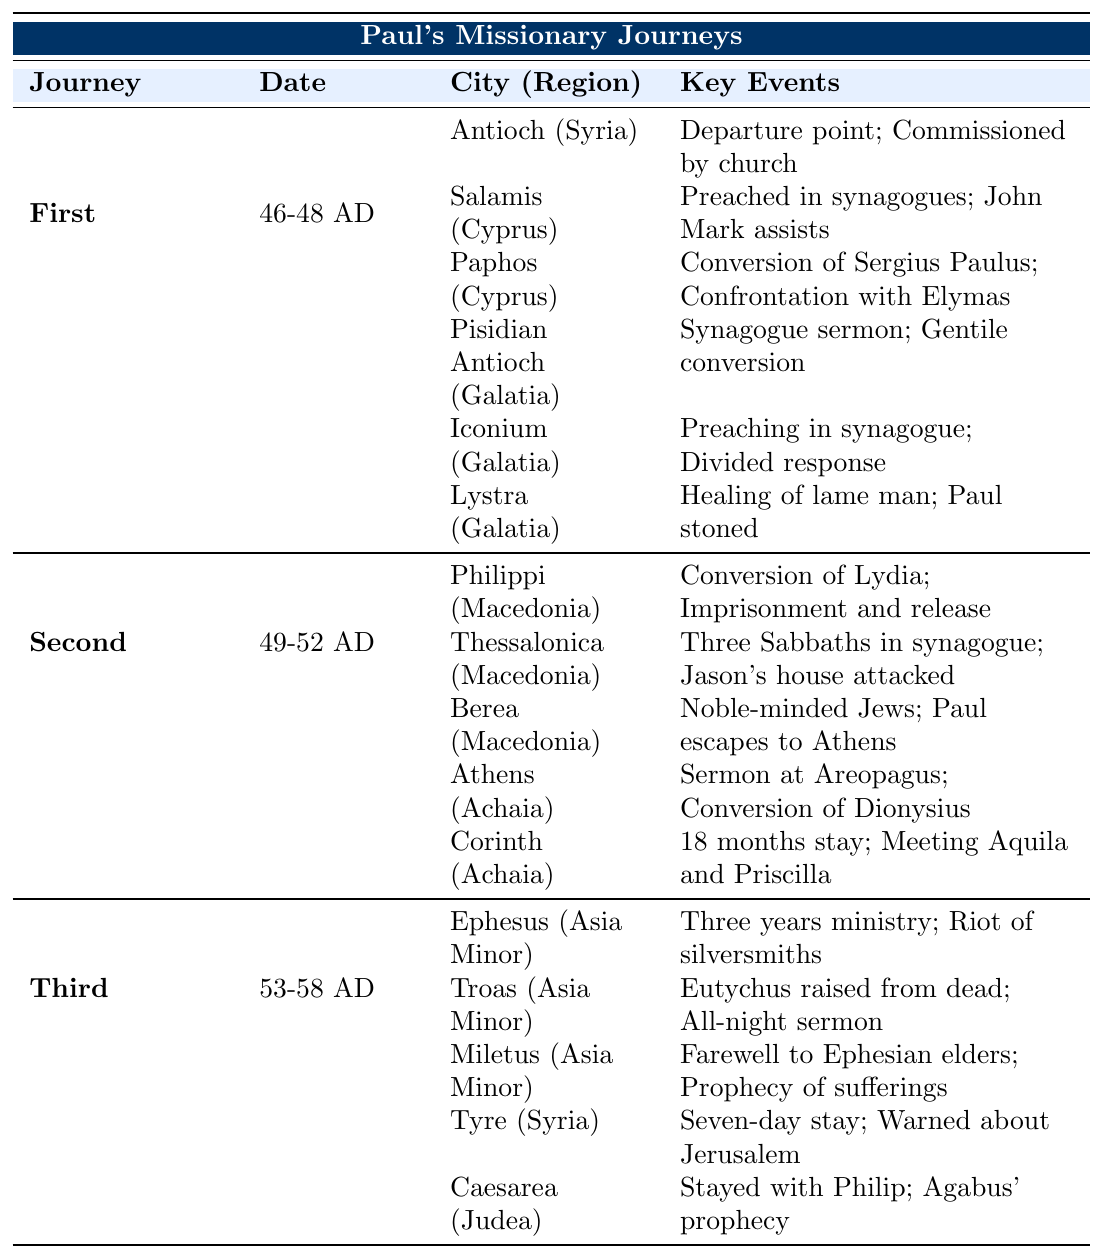What was the date of Paul's First Missionary Journey? According to the table, the First Missionary Journey took place between 46 and 48 AD.
Answer: 46-48 AD Which city in Macedonia was the first that Paul visited during his Second Missionary Journey? The table lists that Paul visited Philippi first in Macedonia during his Second Missionary Journey.
Answer: Philippi Did Paul stay in Ephesus for more than two years during his Third Missionary Journey? The table indicates that Paul had a three-year ministry in Ephesus, which confirms that he stayed for more than two years.
Answer: Yes What were the two key events that took place in Athens during Paul's Second Missionary Journey? The table states that the key events in Athens were the Sermon at the Areopagus and the Conversion of Dionysius.
Answer: Sermon at Areopagus; Conversion of Dionysius In which city did Paul experience a divided response to his preaching during his First Missionary Journey? The table shows that Paul experienced a divided response while preaching in Iconium during his First Missionary Journey.
Answer: Iconium How many cities did Paul visit during his First Missionary Journey? By counting the cities listed in the table under the First Missionary Journey, we find he visited six cities: Antioch, Salamis, Paphos, Pisidian Antioch, Iconium, and Lystra.
Answer: 6 Which two cities did Paul stay in for an extended period during his Second Missionary Journey? The table indicates that Paul stayed for 18 months in Corinth and also spent significant time in Thessalonica (though the duration is not specified, it mentions three Sabbaths). Thus, the figures confirm Corinth and Philippi as extended stays.
Answer: Corinth; Philippi Can you identify a city where Paul faced persecution during his First Missionary Journey? The table notes that Paul was stoned in Lystra, indicating he faced persecution there.
Answer: Lystra What was the nature of the riot mentioned during Paul's stay in Ephesus? In Ephesus, the table lists the Riot of silversmiths as a key event during Paul's ministry.
Answer: Riot of silversmiths Which journey involved a city where Paul converted a notable person named Lydia? According to the table, Lydia was converted in Philippi during Paul's Second Missionary Journey.
Answer: Second Missionary Journey (Philippi) 